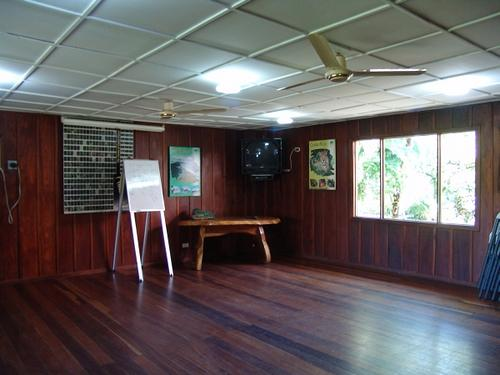What item here would an artist use? Please explain your reasoning. easel. The artist would use the easel. 